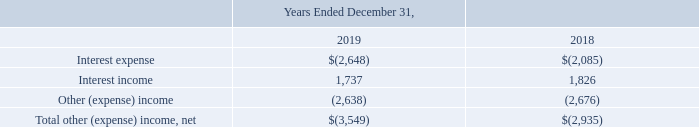Results of Operations: Year Ended December 31, 2019, versus Year Ended December 31, 2018 (Amounts in thousands, except percentages and per share amounts):
Other income and expense items are summarized in the following table:
Interest expense increased mainly as a result of an increase in debt related to the QTI acquisition. Other expense in 2019 was principally driven by foreign currency translation losses, mainly due to the appreciation of the U.S. Dollar compared to the Chinese Renminbi and Euro, as well as an increase in pension expense.
Which years does the table provide information for the company's Other income and expense items? 2019, 2018. What was the primary reason for interest expense increase? Mainly as a result of an increase in debt related to the qti acquisition. What was Other expense in 2019 principally driven by? Foreign currency translation losses, mainly due to the appreciation of the u.s. dollar compared to the chinese renminbi and euro, as well as an increase in pension expense. What was the change in Other (expense) income between 2018 and 2019?
Answer scale should be: thousand. -2,638-(-2,676)
Answer: 38. Which years did Interest income exceed $1,500 thousand? 2019##2018
Answer: 2. What was the percentage change in interest income between 2018 and 2019?
Answer scale should be: percent. (1,737-1,826)/1,826
Answer: -4.87. 